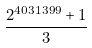Convert formula to latex. <formula><loc_0><loc_0><loc_500><loc_500>\frac { 2 ^ { 4 0 3 1 3 9 9 } + 1 } { 3 }</formula> 